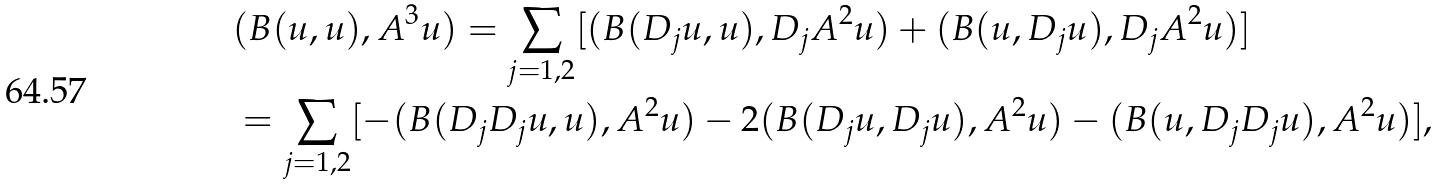Convert formula to latex. <formula><loc_0><loc_0><loc_500><loc_500>& ( B ( u , u ) , A ^ { 3 } u ) = \sum _ { j = 1 , 2 } [ ( B ( D _ { j } u , u ) , D _ { j } A ^ { 2 } u ) + ( B ( u , D _ { j } u ) , D _ { j } A ^ { 2 } u ) ] \\ & = \sum _ { j = 1 , 2 } [ - ( B ( D _ { j } D _ { j } u , u ) , A ^ { 2 } u ) - 2 ( B ( D _ { j } u , D _ { j } u ) , A ^ { 2 } u ) - ( B ( u , D _ { j } D _ { j } u ) , A ^ { 2 } u ) ] ,</formula> 